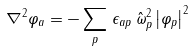<formula> <loc_0><loc_0><loc_500><loc_500>\nabla ^ { 2 } \varphi _ { a } = - \sum _ { p } \, \epsilon _ { a p } \, \hat { \omega } ^ { 2 } _ { p } \left | \varphi _ { p } \right | ^ { 2 }</formula> 